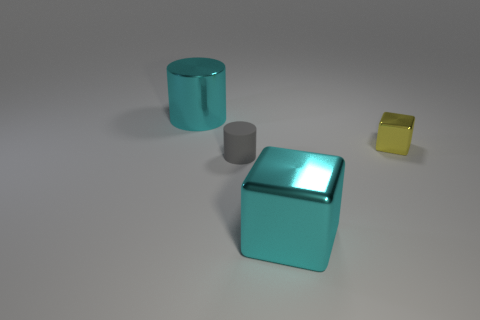Add 1 small green matte cylinders. How many objects exist? 5 Subtract all cyan cylinders. How many cylinders are left? 1 Subtract 1 cubes. How many cubes are left? 1 Subtract all purple cylinders. Subtract all tiny objects. How many objects are left? 2 Add 1 big metallic blocks. How many big metallic blocks are left? 2 Add 3 small gray matte cylinders. How many small gray matte cylinders exist? 4 Subtract 0 purple balls. How many objects are left? 4 Subtract all gray blocks. Subtract all yellow spheres. How many blocks are left? 2 